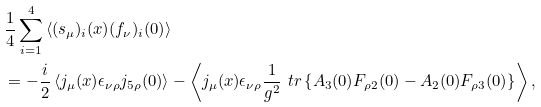<formula> <loc_0><loc_0><loc_500><loc_500>& \frac { 1 } { 4 } \sum _ { i = 1 } ^ { 4 } \left \langle ( s _ { \mu } ) _ { i } ( x ) ( f _ { \nu } ) _ { i } ( 0 ) \right \rangle \\ & = - \frac { i } { 2 } \left \langle j _ { \mu } ( x ) \epsilon _ { \nu \rho } j _ { 5 \rho } ( 0 ) \right \rangle - \left \langle j _ { \mu } ( x ) \epsilon _ { \nu \rho } \frac { 1 } { g ^ { 2 } } \ t r \left \{ A _ { 3 } ( 0 ) F _ { \rho 2 } ( 0 ) - A _ { 2 } ( 0 ) F _ { \rho 3 } ( 0 ) \right \} \right \rangle ,</formula> 